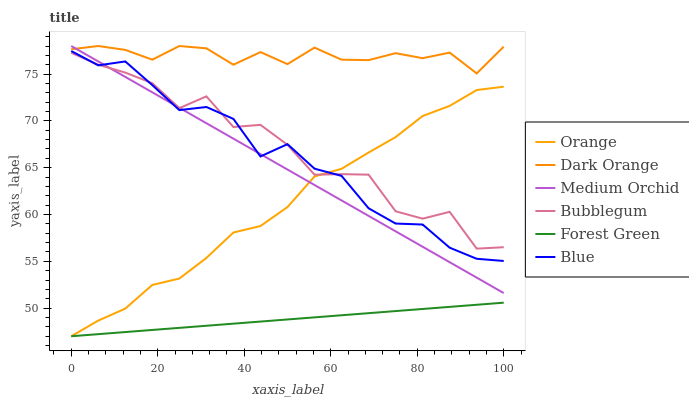Does Forest Green have the minimum area under the curve?
Answer yes or no. Yes. Does Dark Orange have the maximum area under the curve?
Answer yes or no. Yes. Does Medium Orchid have the minimum area under the curve?
Answer yes or no. No. Does Medium Orchid have the maximum area under the curve?
Answer yes or no. No. Is Medium Orchid the smoothest?
Answer yes or no. Yes. Is Bubblegum the roughest?
Answer yes or no. Yes. Is Dark Orange the smoothest?
Answer yes or no. No. Is Dark Orange the roughest?
Answer yes or no. No. Does Forest Green have the lowest value?
Answer yes or no. Yes. Does Medium Orchid have the lowest value?
Answer yes or no. No. Does Medium Orchid have the highest value?
Answer yes or no. Yes. Does Bubblegum have the highest value?
Answer yes or no. No. Is Forest Green less than Bubblegum?
Answer yes or no. Yes. Is Dark Orange greater than Bubblegum?
Answer yes or no. Yes. Does Orange intersect Blue?
Answer yes or no. Yes. Is Orange less than Blue?
Answer yes or no. No. Is Orange greater than Blue?
Answer yes or no. No. Does Forest Green intersect Bubblegum?
Answer yes or no. No. 